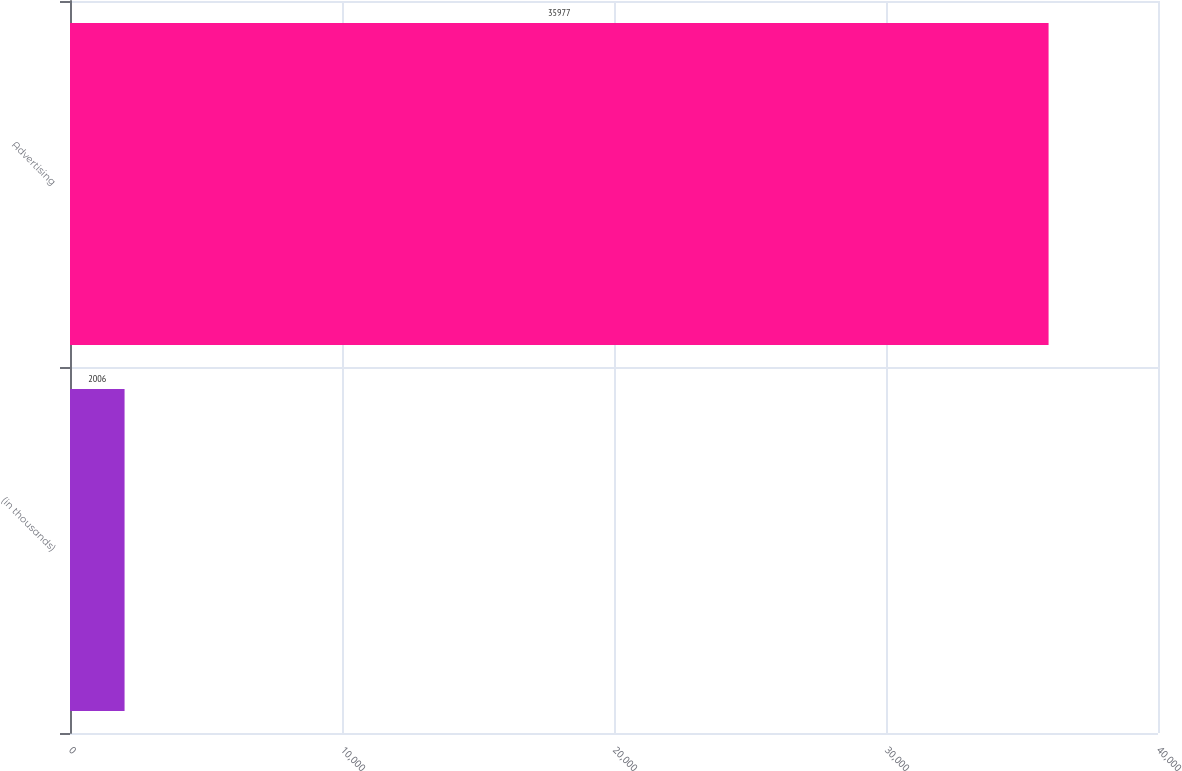Convert chart to OTSL. <chart><loc_0><loc_0><loc_500><loc_500><bar_chart><fcel>(in thousands)<fcel>Advertising<nl><fcel>2006<fcel>35977<nl></chart> 